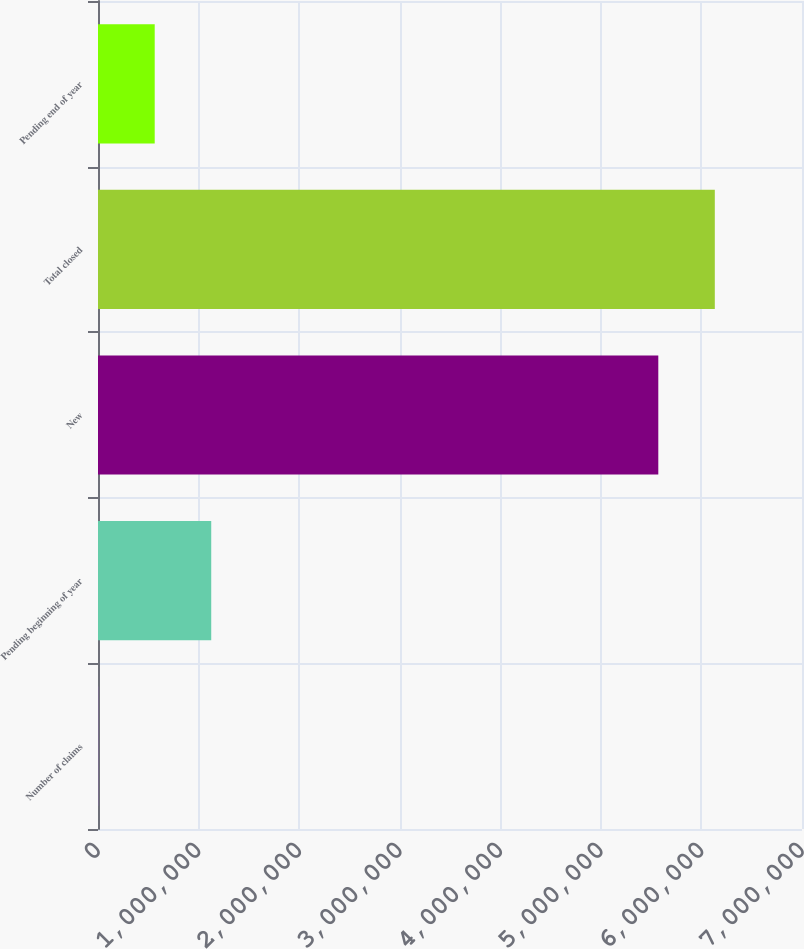Convert chart. <chart><loc_0><loc_0><loc_500><loc_500><bar_chart><fcel>Number of claims<fcel>Pending beginning of year<fcel>New<fcel>Total closed<fcel>Pending end of year<nl><fcel>2010<fcel>1.12584e+06<fcel>5.5712e+06<fcel>6.13311e+06<fcel>563925<nl></chart> 